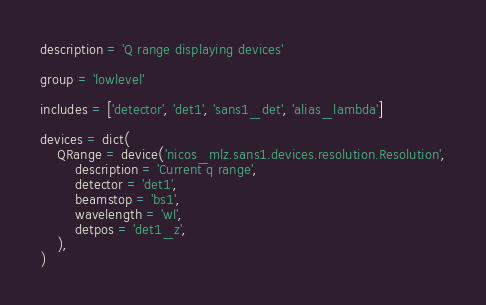<code> <loc_0><loc_0><loc_500><loc_500><_Python_>description = 'Q range displaying devices'

group = 'lowlevel'

includes = ['detector', 'det1', 'sans1_det', 'alias_lambda']

devices = dict(
    QRange = device('nicos_mlz.sans1.devices.resolution.Resolution',
        description = 'Current q range',
        detector = 'det1',
        beamstop = 'bs1',
        wavelength = 'wl',
        detpos = 'det1_z',
    ),
)
</code> 